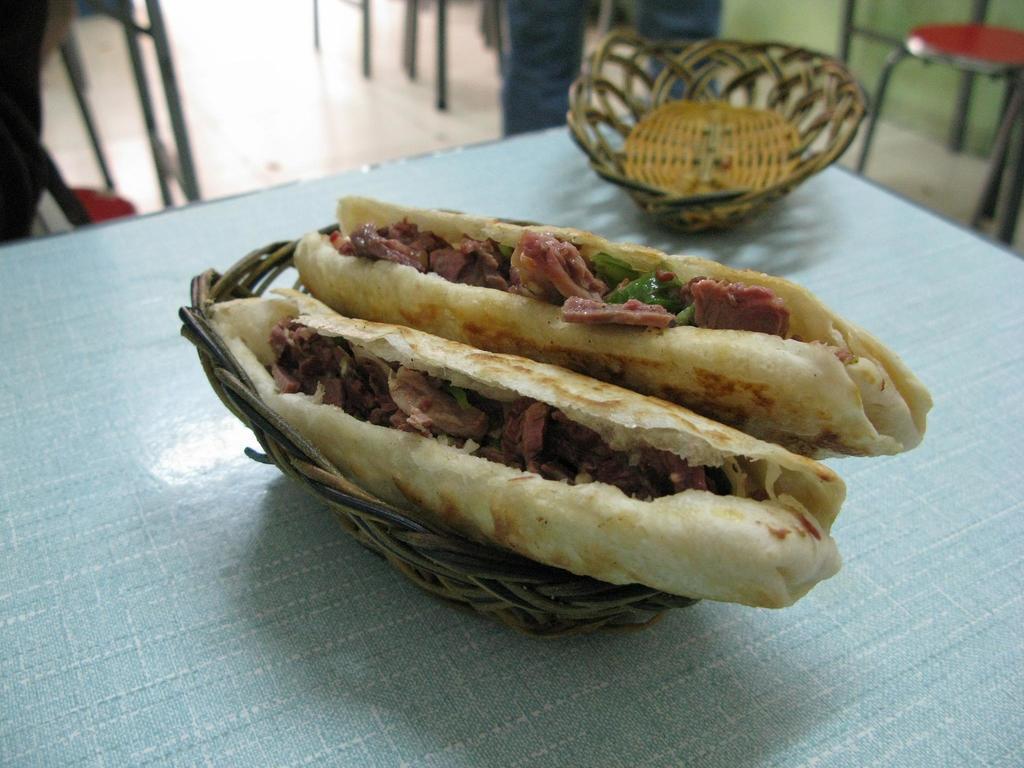Please provide a concise description of this image. In this image there are two sandwiches in the basket , and there is another basket on the table, and in the background there are chairs and a person. 